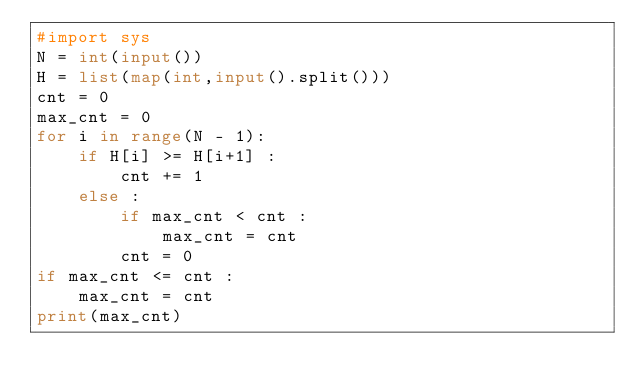Convert code to text. <code><loc_0><loc_0><loc_500><loc_500><_Python_>#import sys
N = int(input())
H = list(map(int,input().split()))
cnt = 0
max_cnt = 0
for i in range(N - 1):
    if H[i] >= H[i+1] :
        cnt += 1
    else :
        if max_cnt < cnt :
            max_cnt = cnt
        cnt = 0
if max_cnt <= cnt :
    max_cnt = cnt
print(max_cnt)</code> 